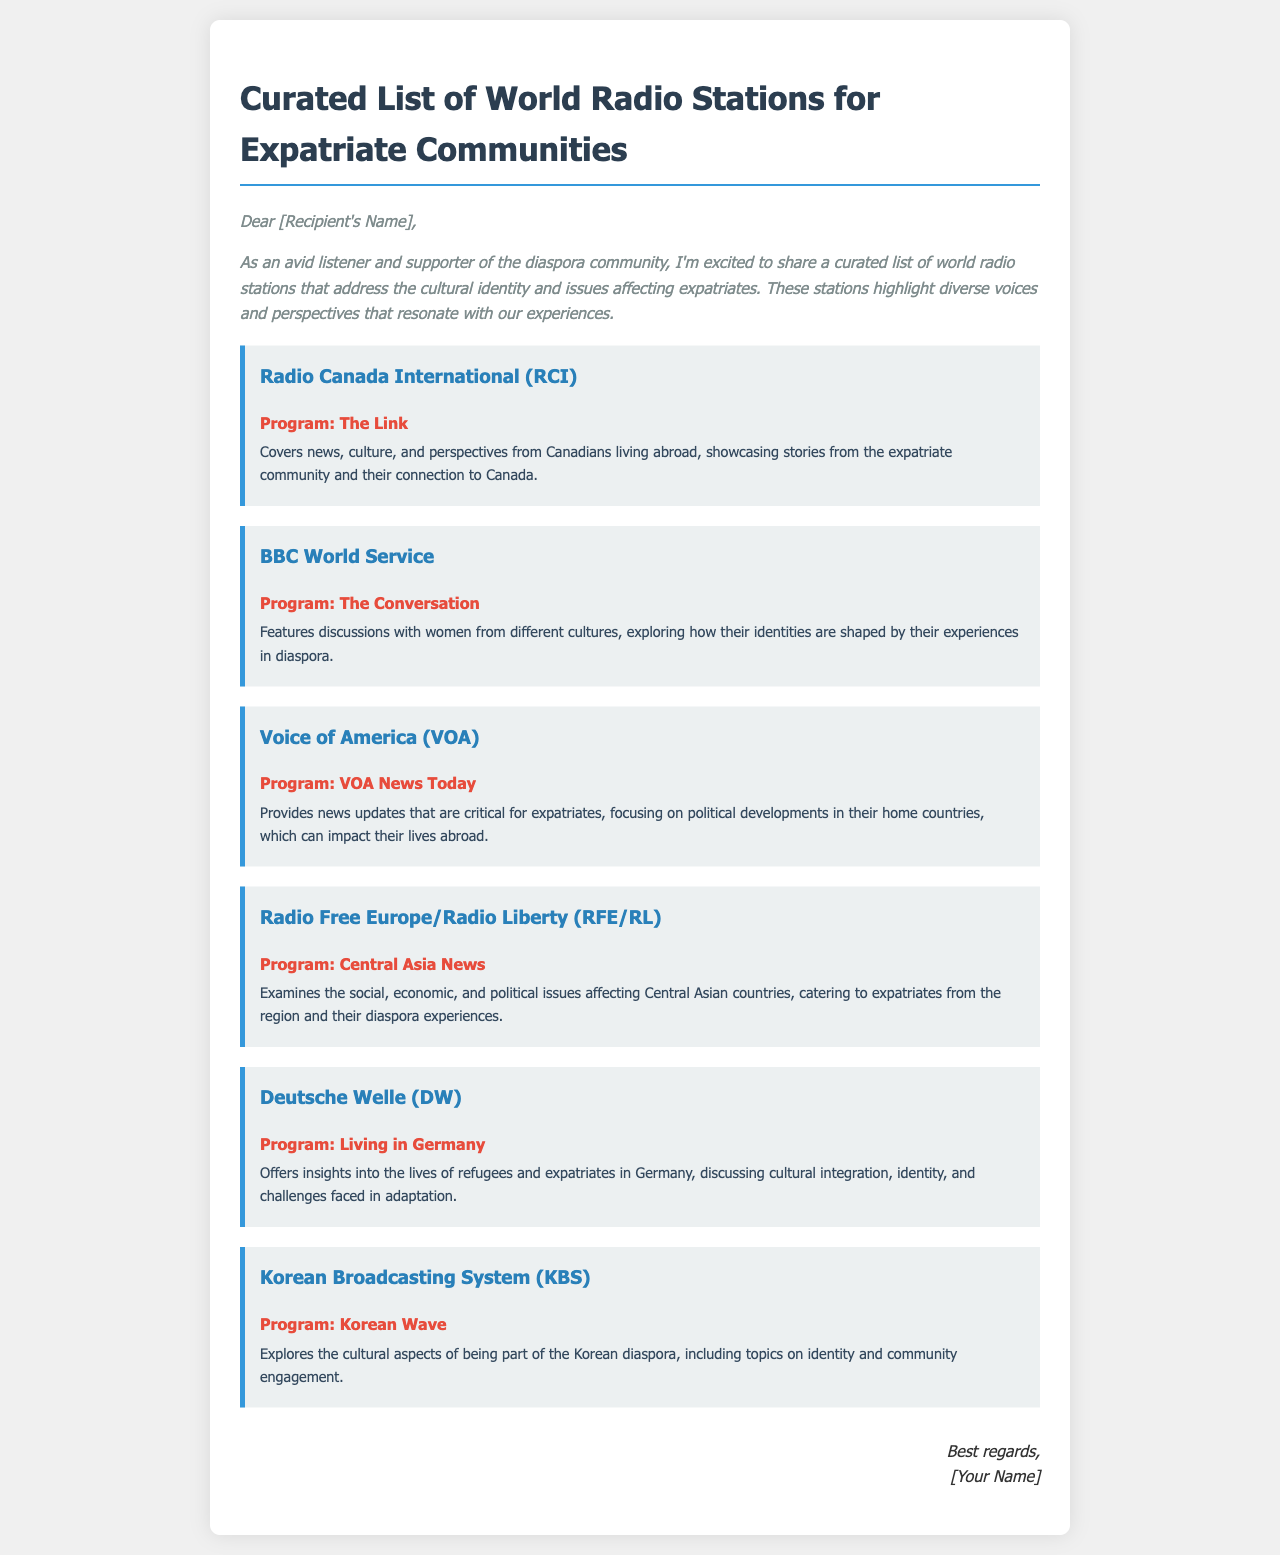What is the title of the document? The title is stated at the top of the document and introduces the subject matter of the curated list.
Answer: Curated List of World Radio Stations for Expatriate Communities Who is the first radio station mentioned? The first station is highlighted in the document, focusing on its name and program offered.
Answer: Radio Canada International (RCI) What program does the BBC World Service offer? The document specifies the program name associated with the BBC World Service.
Answer: The Conversation What is the focus of the program "VOA News Today"? The document outlines the themes and topics that this particular program addresses for expatriates.
Answer: Provides news updates that are critical for expatriates How many radio stations are listed in the document? The document enumerates the radio stations included in the curated list for expatriate communities.
Answer: Six What common theme do the radio programs share? The document highlights the overarching topics that the recommended programs focus on related to expatriate experiences.
Answer: Cultural identity and issues affecting expatriates What element of the document indicates it is a recommendation? The structure and language used in the introduction convey that the document is providing suggestions for listening options.
Answer: Curated list Who is the intended audience for this document? The introduction specifies the groups of people the document is aimed at, reflecting their interests and community concerns.
Answer: Expatriate communities 